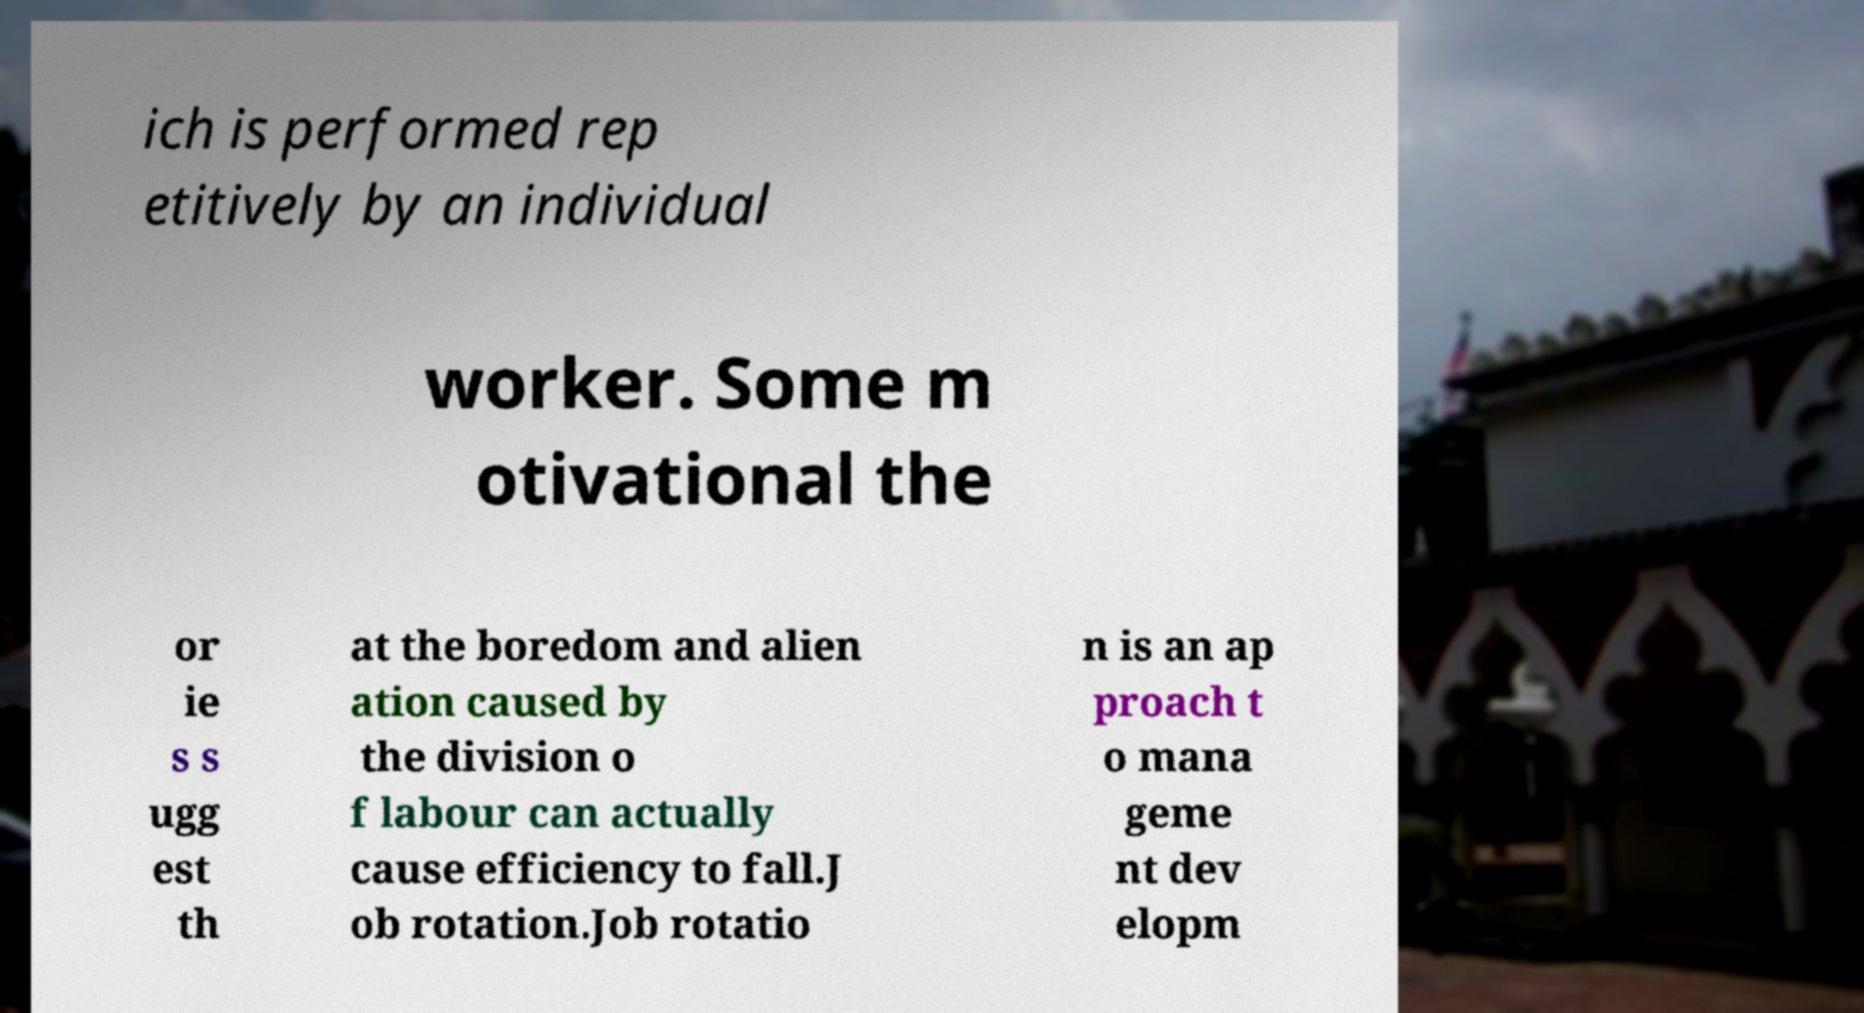Can you accurately transcribe the text from the provided image for me? ich is performed rep etitively by an individual worker. Some m otivational the or ie s s ugg est th at the boredom and alien ation caused by the division o f labour can actually cause efficiency to fall.J ob rotation.Job rotatio n is an ap proach t o mana geme nt dev elopm 